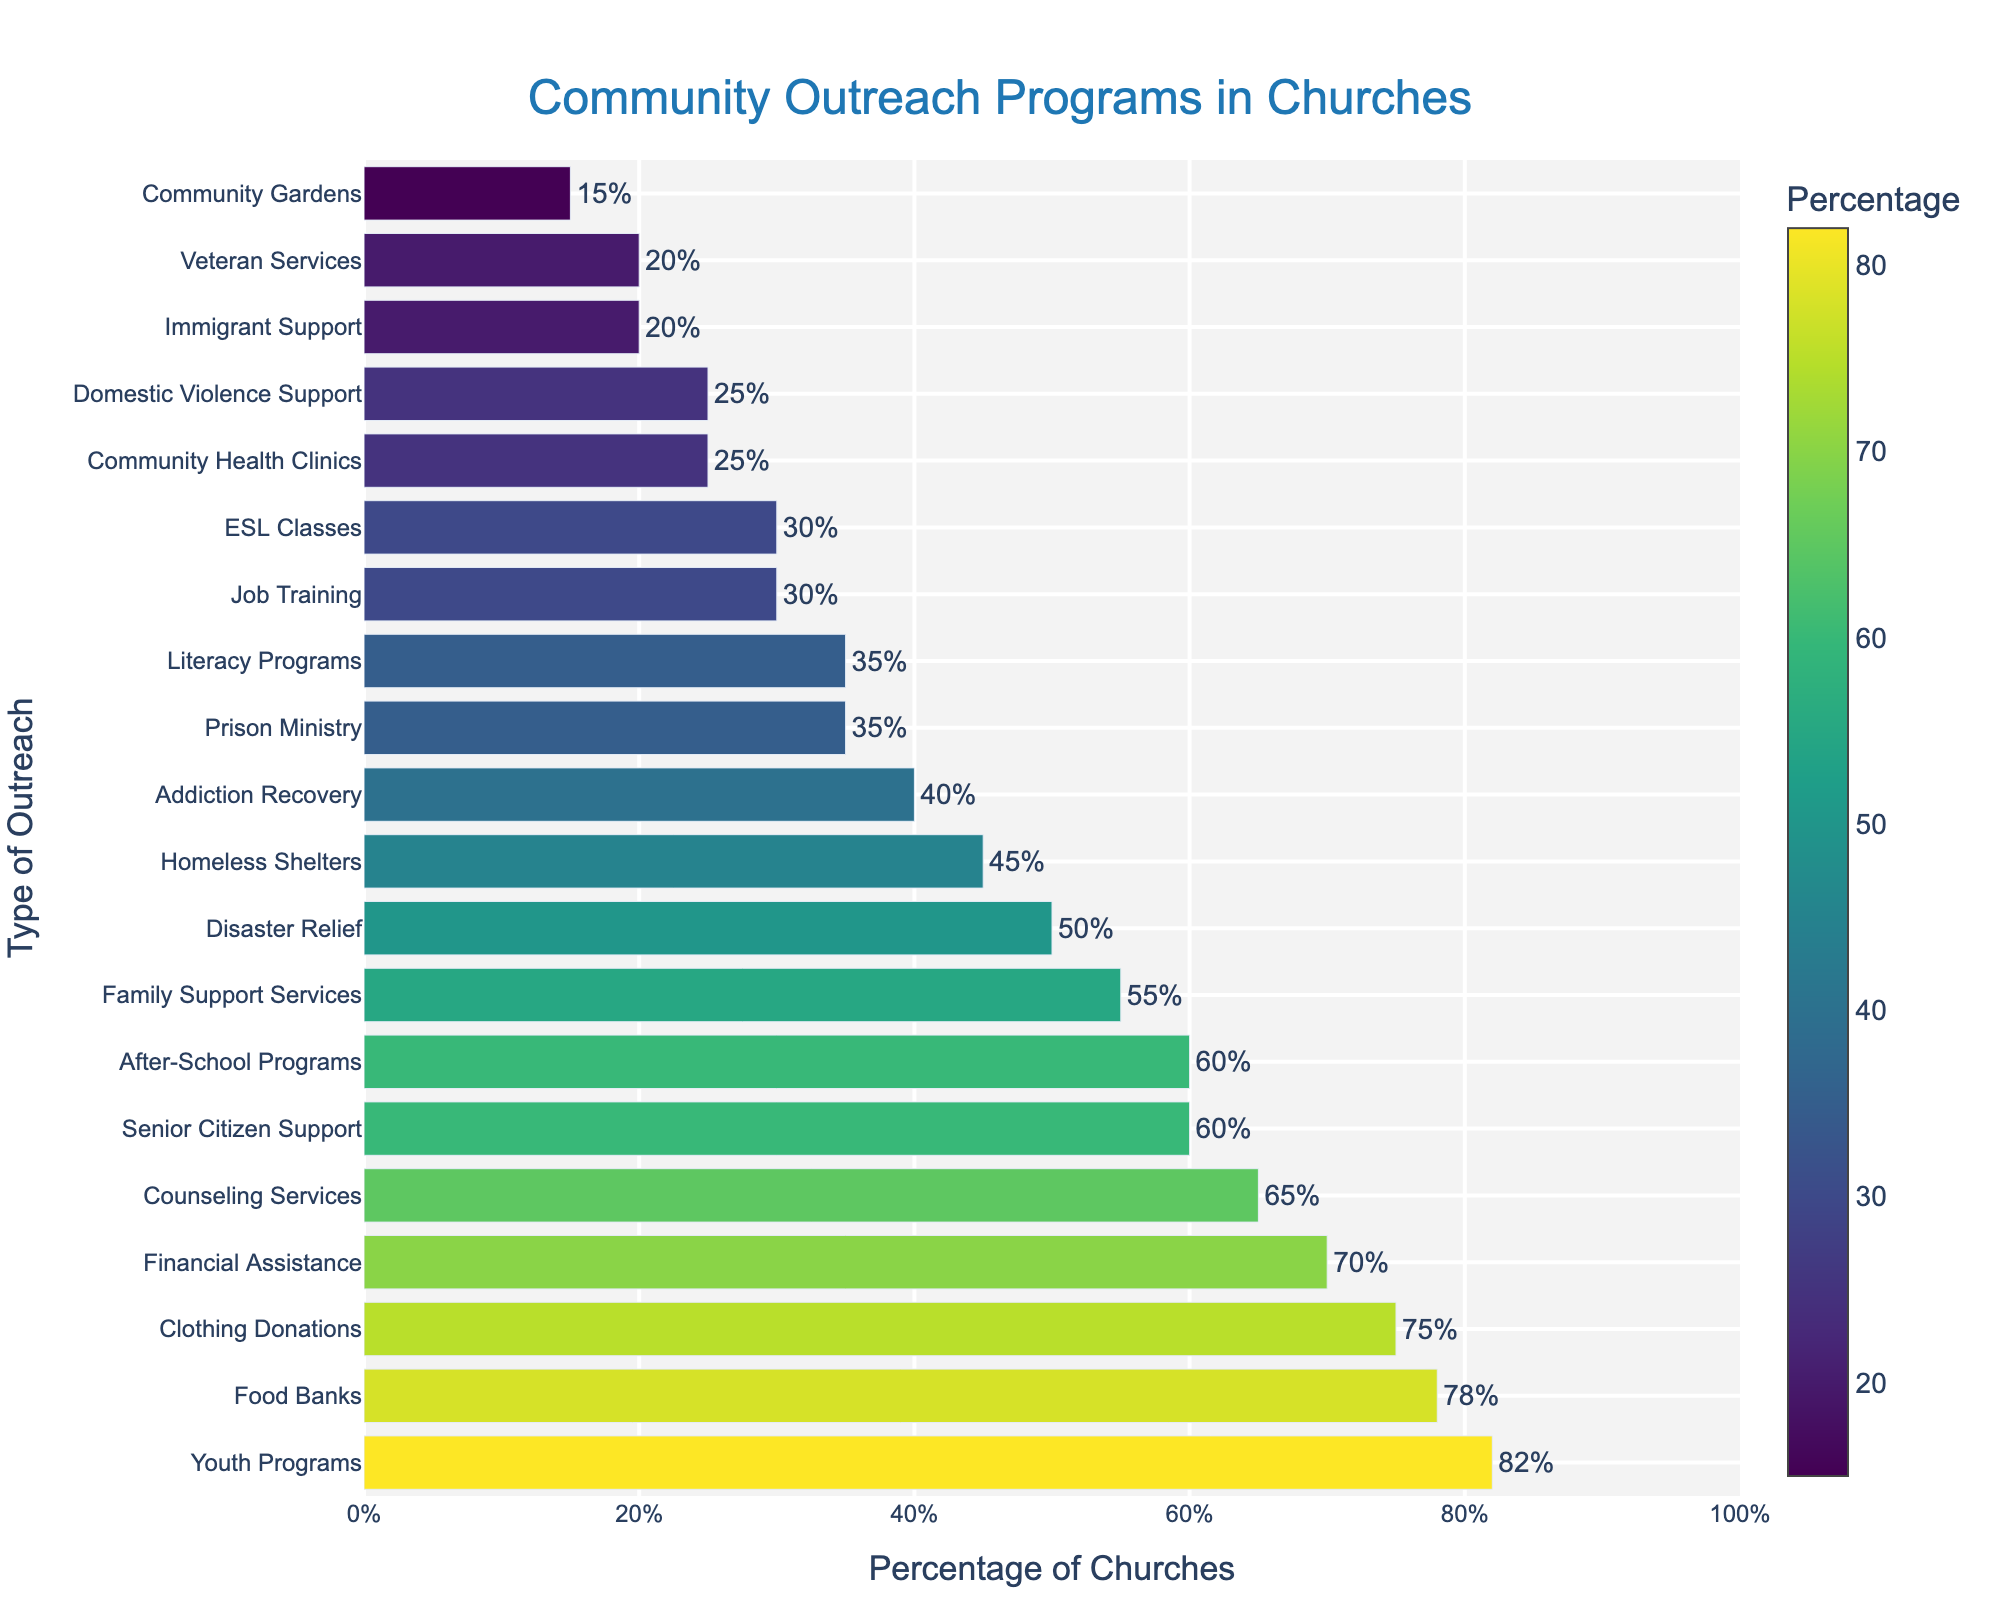What's the most common type of community outreach program among churches? The most common type is the one with the highest bar in the chart. In this case, it's Youth Programs with 82%.
Answer: Youth Programs Which community outreach program is the least common among churches? The least common type is the one with the smallest bar in the chart. Community Gardens is at the bottom with 15%.
Answer: Community Gardens How many community outreach programs have a percentage of churches participating that is 50% or higher? We look at the figure and count the number of bars that reach or exceed the 50% mark. They are: Food Banks, Youth Programs, Counseling Services, Senior Citizen Support, Family Support Services, Disaster Relief, Financial Assistance, and Clothing Donations, making it a total of 8 programs.
Answer: 8 Which outreach program is represented by the darkest color on the chart? The darkest color corresponds to the highest percentage, which is Youth Programs at 82%.
Answer: Youth Programs What's the difference in the percentage of churches offering Food Banks versus those offering Job Training? First, identify the percentages for both: Food Banks is 78%, and Job Training is 30%. The difference is 78% - 30% = 48%.
Answer: 48% Between Addiction Recovery and Literacy Programs, which type of outreach has a higher percentage of churches participating? Compare the heights of the bars for Addiction Recovery (40%) and Literacy Programs (35%). Addiction Recovery has a higher percentage.
Answer: Addiction Recovery What is the sum of percentages for churches offering Youth Programs and Counseling Services? Youth Programs is at 82% and Counseling Services is at 65%. Adding these together gives 82% + 65% = 147%.
Answer: 147% Which type of outreach has a percentage of churches exactly between that of Homeless Shelters and Family Support Services? Homeless Shelters are at 45% and Family Support Services at 55%. The type of outreach in between these values is Disaster Relief, which is at 50%.
Answer: Disaster Relief What is the range of percentages (difference between the highest and lowest percentages) depicted in the chart? The highest percentage is 82% (Youth Programs) and the lowest is 15% (Community Gardens). The range is 82% - 15% = 67%.
Answer: 67% Which programs have exactly 35% participation? Identify the bars that reach up to the 35% level in the chart. These are Literacy Programs and Prison Ministry.
Answer: Literacy Programs and Prison Ministry 